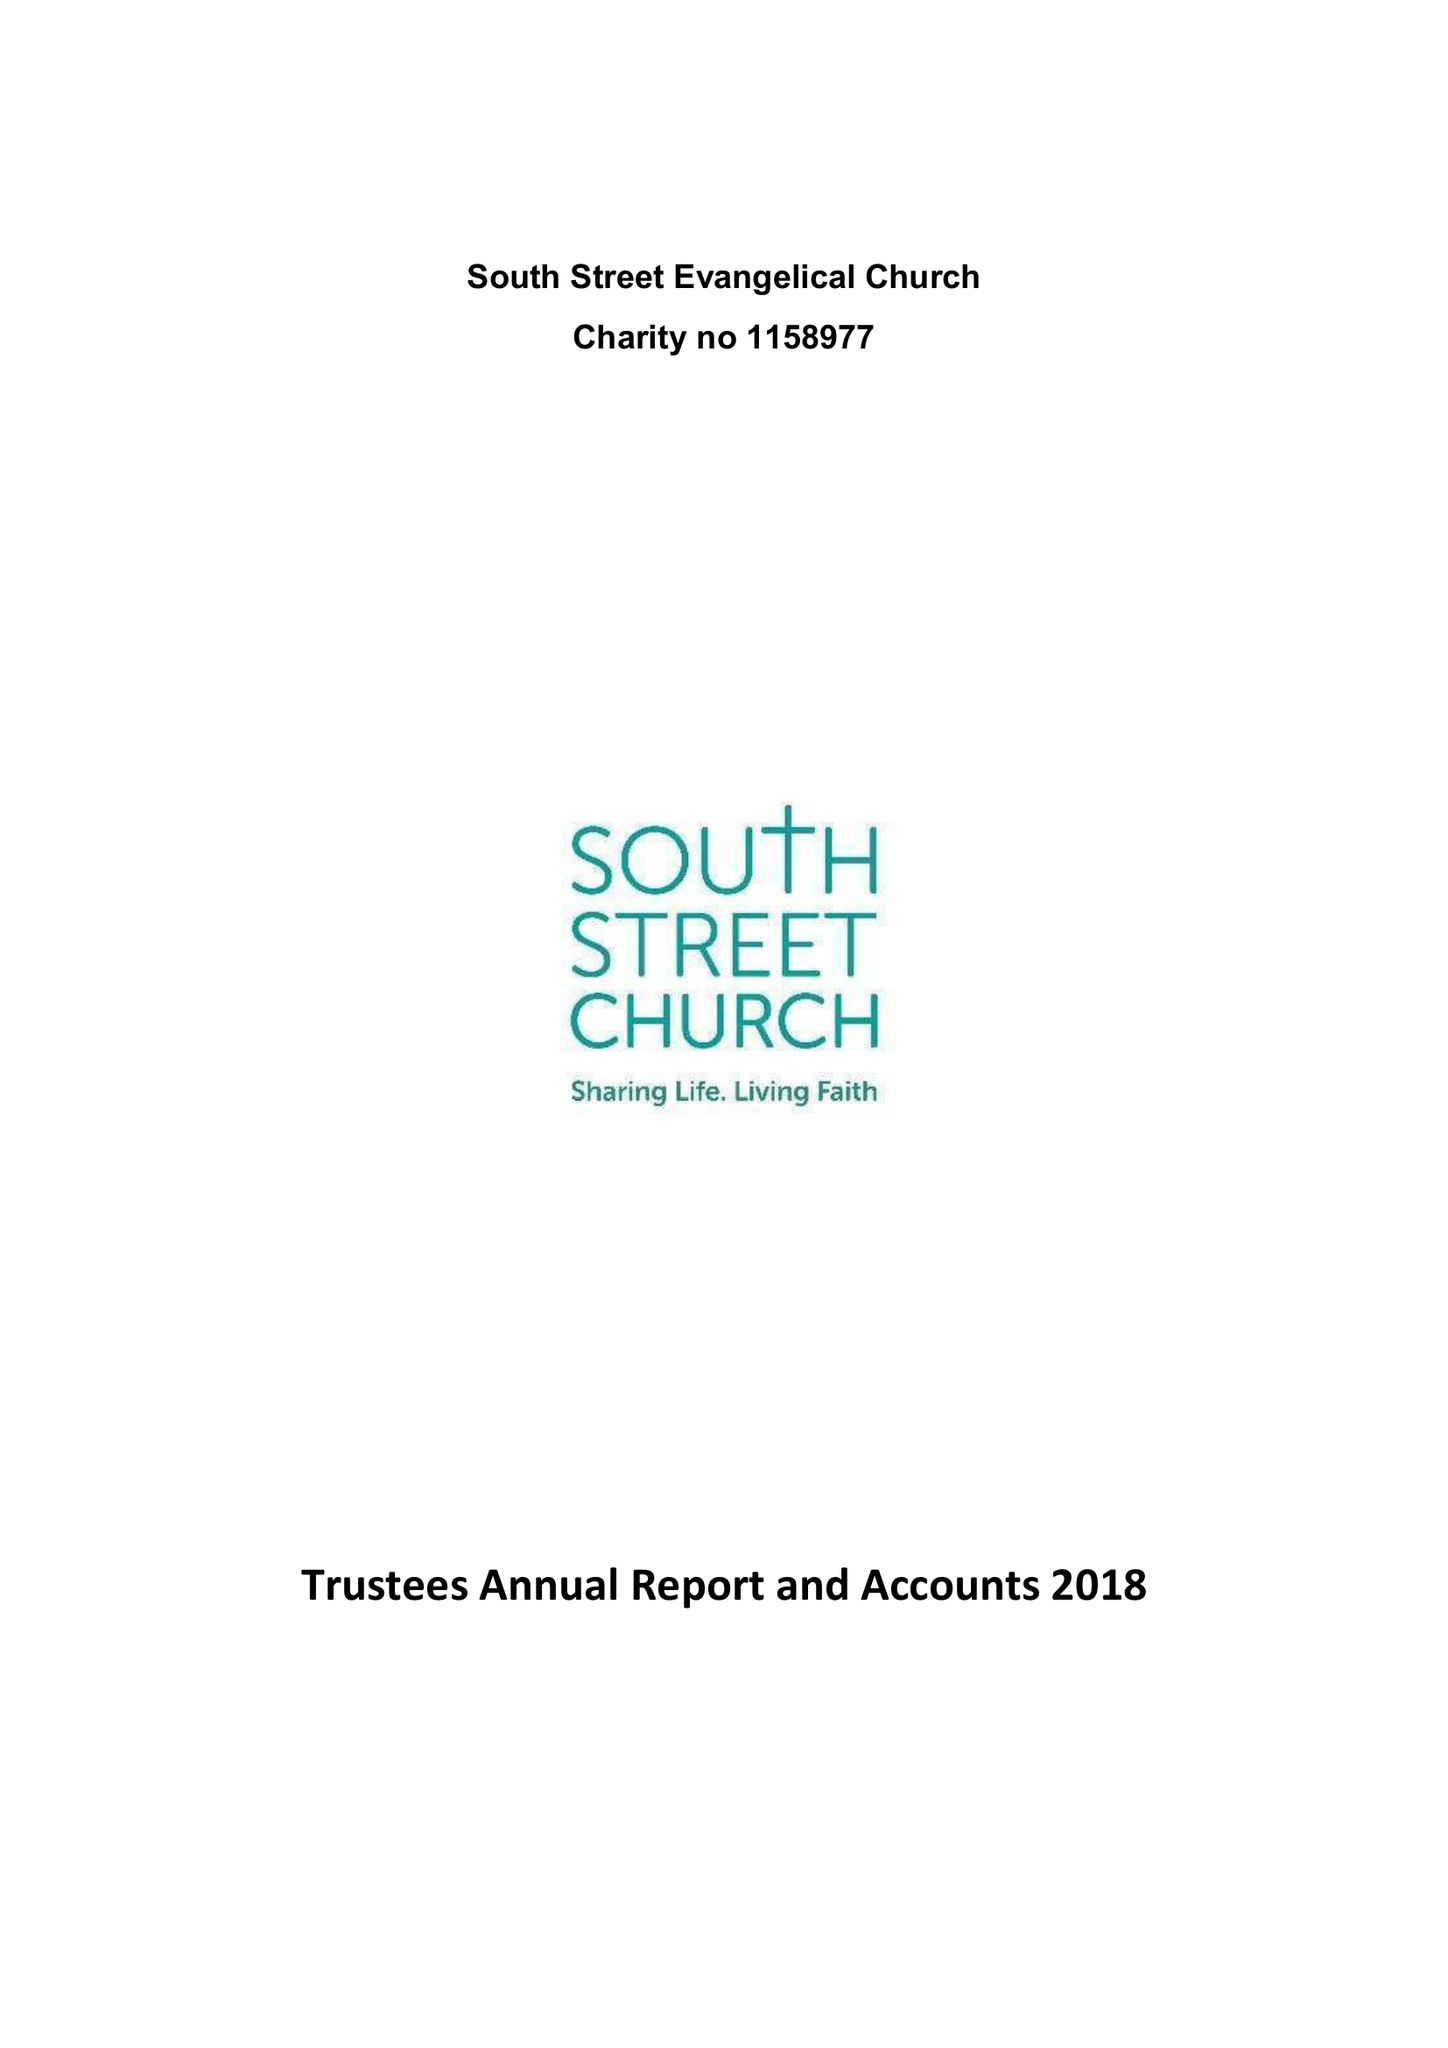What is the value for the address__street_line?
Answer the question using a single word or phrase. SOUTH STREET 